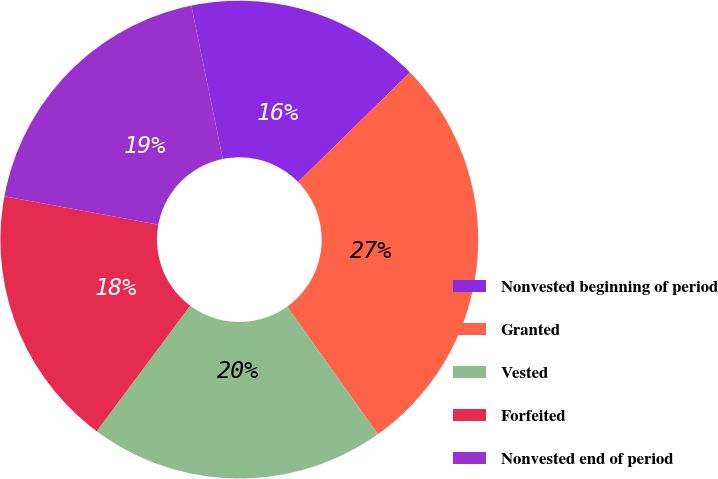<chart> <loc_0><loc_0><loc_500><loc_500><pie_chart><fcel>Nonvested beginning of period<fcel>Granted<fcel>Vested<fcel>Forfeited<fcel>Nonvested end of period<nl><fcel>15.88%<fcel>27.49%<fcel>20.04%<fcel>17.72%<fcel>18.88%<nl></chart> 